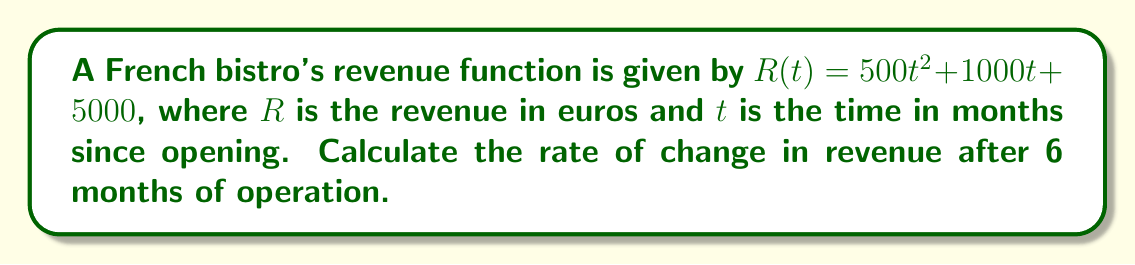Help me with this question. To find the rate of change in revenue after 6 months, we need to calculate the derivative of the revenue function and evaluate it at $t = 6$.

Step 1: Find the derivative of the revenue function.
The revenue function is $R(t) = 500t^2 + 1000t + 5000$
Using the power rule and constant rule:
$$R'(t) = 1000t + 1000$$

Step 2: Evaluate the derivative at $t = 6$.
$$R'(6) = 1000(6) + 1000$$
$$R'(6) = 6000 + 1000$$
$$R'(6) = 7000$$

Therefore, after 6 months of operation, the rate of change in revenue is 7000 euros per month.
Answer: 7000 euros/month 